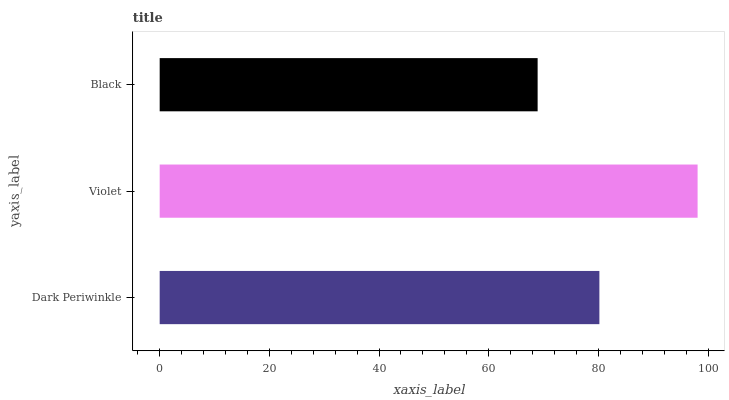Is Black the minimum?
Answer yes or no. Yes. Is Violet the maximum?
Answer yes or no. Yes. Is Violet the minimum?
Answer yes or no. No. Is Black the maximum?
Answer yes or no. No. Is Violet greater than Black?
Answer yes or no. Yes. Is Black less than Violet?
Answer yes or no. Yes. Is Black greater than Violet?
Answer yes or no. No. Is Violet less than Black?
Answer yes or no. No. Is Dark Periwinkle the high median?
Answer yes or no. Yes. Is Dark Periwinkle the low median?
Answer yes or no. Yes. Is Violet the high median?
Answer yes or no. No. Is Violet the low median?
Answer yes or no. No. 